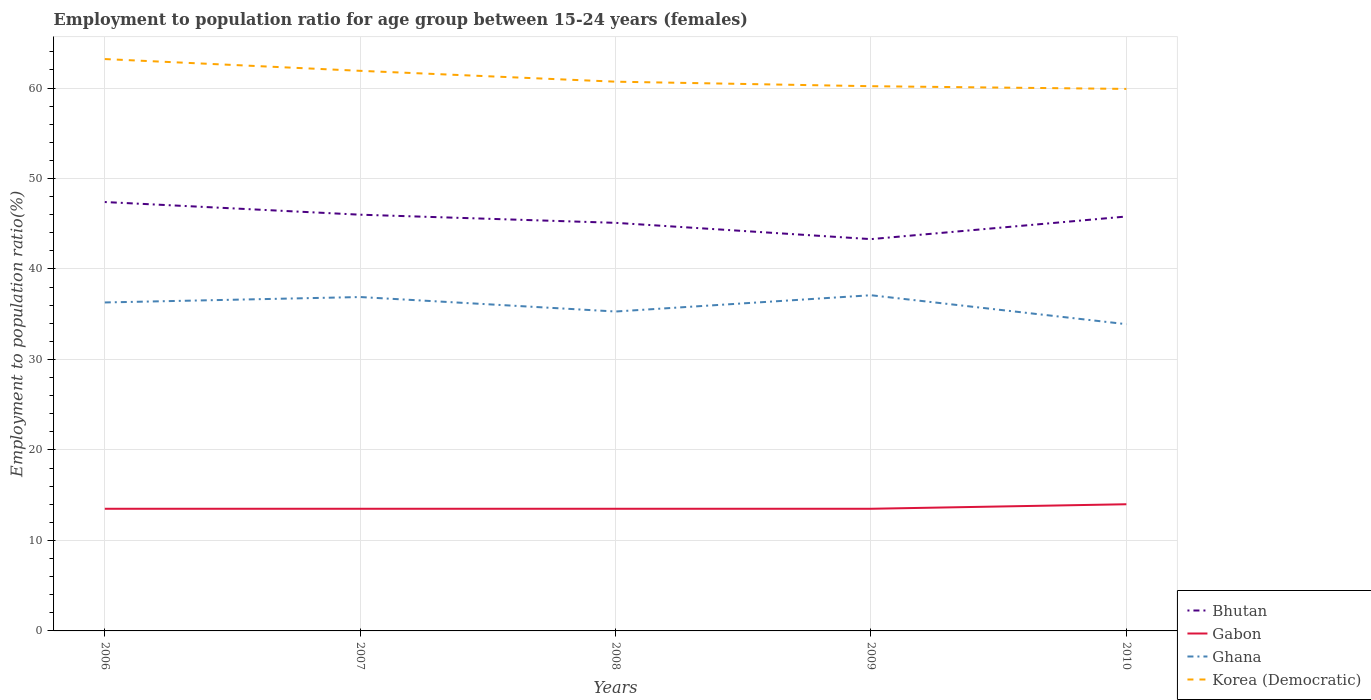How many different coloured lines are there?
Offer a very short reply. 4. Across all years, what is the maximum employment to population ratio in Korea (Democratic)?
Give a very brief answer. 59.9. What is the total employment to population ratio in Bhutan in the graph?
Offer a terse response. 0.9. What is the difference between the highest and the second highest employment to population ratio in Bhutan?
Provide a short and direct response. 4.1. How many years are there in the graph?
Give a very brief answer. 5. Are the values on the major ticks of Y-axis written in scientific E-notation?
Ensure brevity in your answer.  No. Does the graph contain any zero values?
Offer a very short reply. No. Does the graph contain grids?
Keep it short and to the point. Yes. How many legend labels are there?
Make the answer very short. 4. What is the title of the graph?
Your answer should be very brief. Employment to population ratio for age group between 15-24 years (females). Does "Least developed countries" appear as one of the legend labels in the graph?
Your response must be concise. No. What is the label or title of the X-axis?
Make the answer very short. Years. What is the Employment to population ratio(%) of Bhutan in 2006?
Offer a very short reply. 47.4. What is the Employment to population ratio(%) of Ghana in 2006?
Your answer should be compact. 36.3. What is the Employment to population ratio(%) of Korea (Democratic) in 2006?
Provide a short and direct response. 63.2. What is the Employment to population ratio(%) in Bhutan in 2007?
Make the answer very short. 46. What is the Employment to population ratio(%) in Ghana in 2007?
Your answer should be compact. 36.9. What is the Employment to population ratio(%) of Korea (Democratic) in 2007?
Provide a short and direct response. 61.9. What is the Employment to population ratio(%) of Bhutan in 2008?
Offer a terse response. 45.1. What is the Employment to population ratio(%) of Gabon in 2008?
Offer a terse response. 13.5. What is the Employment to population ratio(%) of Ghana in 2008?
Provide a short and direct response. 35.3. What is the Employment to population ratio(%) in Korea (Democratic) in 2008?
Your answer should be compact. 60.7. What is the Employment to population ratio(%) in Bhutan in 2009?
Make the answer very short. 43.3. What is the Employment to population ratio(%) of Ghana in 2009?
Your answer should be compact. 37.1. What is the Employment to population ratio(%) in Korea (Democratic) in 2009?
Keep it short and to the point. 60.2. What is the Employment to population ratio(%) of Bhutan in 2010?
Give a very brief answer. 45.8. What is the Employment to population ratio(%) in Ghana in 2010?
Offer a very short reply. 33.9. What is the Employment to population ratio(%) in Korea (Democratic) in 2010?
Make the answer very short. 59.9. Across all years, what is the maximum Employment to population ratio(%) of Bhutan?
Make the answer very short. 47.4. Across all years, what is the maximum Employment to population ratio(%) in Ghana?
Ensure brevity in your answer.  37.1. Across all years, what is the maximum Employment to population ratio(%) in Korea (Democratic)?
Provide a succinct answer. 63.2. Across all years, what is the minimum Employment to population ratio(%) of Bhutan?
Offer a terse response. 43.3. Across all years, what is the minimum Employment to population ratio(%) in Ghana?
Ensure brevity in your answer.  33.9. Across all years, what is the minimum Employment to population ratio(%) of Korea (Democratic)?
Offer a very short reply. 59.9. What is the total Employment to population ratio(%) of Bhutan in the graph?
Your response must be concise. 227.6. What is the total Employment to population ratio(%) of Ghana in the graph?
Offer a terse response. 179.5. What is the total Employment to population ratio(%) in Korea (Democratic) in the graph?
Offer a very short reply. 305.9. What is the difference between the Employment to population ratio(%) in Gabon in 2006 and that in 2007?
Keep it short and to the point. 0. What is the difference between the Employment to population ratio(%) of Gabon in 2006 and that in 2008?
Provide a succinct answer. 0. What is the difference between the Employment to population ratio(%) in Korea (Democratic) in 2006 and that in 2008?
Your answer should be compact. 2.5. What is the difference between the Employment to population ratio(%) of Bhutan in 2006 and that in 2009?
Make the answer very short. 4.1. What is the difference between the Employment to population ratio(%) of Bhutan in 2007 and that in 2008?
Give a very brief answer. 0.9. What is the difference between the Employment to population ratio(%) in Ghana in 2007 and that in 2008?
Your answer should be compact. 1.6. What is the difference between the Employment to population ratio(%) in Gabon in 2007 and that in 2009?
Make the answer very short. 0. What is the difference between the Employment to population ratio(%) in Ghana in 2007 and that in 2009?
Your answer should be very brief. -0.2. What is the difference between the Employment to population ratio(%) of Ghana in 2007 and that in 2010?
Provide a short and direct response. 3. What is the difference between the Employment to population ratio(%) in Bhutan in 2008 and that in 2009?
Your response must be concise. 1.8. What is the difference between the Employment to population ratio(%) in Korea (Democratic) in 2008 and that in 2009?
Offer a terse response. 0.5. What is the difference between the Employment to population ratio(%) in Gabon in 2009 and that in 2010?
Keep it short and to the point. -0.5. What is the difference between the Employment to population ratio(%) of Ghana in 2009 and that in 2010?
Your response must be concise. 3.2. What is the difference between the Employment to population ratio(%) of Korea (Democratic) in 2009 and that in 2010?
Provide a short and direct response. 0.3. What is the difference between the Employment to population ratio(%) in Bhutan in 2006 and the Employment to population ratio(%) in Gabon in 2007?
Make the answer very short. 33.9. What is the difference between the Employment to population ratio(%) of Gabon in 2006 and the Employment to population ratio(%) of Ghana in 2007?
Make the answer very short. -23.4. What is the difference between the Employment to population ratio(%) of Gabon in 2006 and the Employment to population ratio(%) of Korea (Democratic) in 2007?
Your answer should be compact. -48.4. What is the difference between the Employment to population ratio(%) of Ghana in 2006 and the Employment to population ratio(%) of Korea (Democratic) in 2007?
Make the answer very short. -25.6. What is the difference between the Employment to population ratio(%) in Bhutan in 2006 and the Employment to population ratio(%) in Gabon in 2008?
Keep it short and to the point. 33.9. What is the difference between the Employment to population ratio(%) of Bhutan in 2006 and the Employment to population ratio(%) of Korea (Democratic) in 2008?
Your answer should be compact. -13.3. What is the difference between the Employment to population ratio(%) of Gabon in 2006 and the Employment to population ratio(%) of Ghana in 2008?
Offer a terse response. -21.8. What is the difference between the Employment to population ratio(%) of Gabon in 2006 and the Employment to population ratio(%) of Korea (Democratic) in 2008?
Keep it short and to the point. -47.2. What is the difference between the Employment to population ratio(%) in Ghana in 2006 and the Employment to population ratio(%) in Korea (Democratic) in 2008?
Give a very brief answer. -24.4. What is the difference between the Employment to population ratio(%) in Bhutan in 2006 and the Employment to population ratio(%) in Gabon in 2009?
Your response must be concise. 33.9. What is the difference between the Employment to population ratio(%) in Bhutan in 2006 and the Employment to population ratio(%) in Ghana in 2009?
Offer a very short reply. 10.3. What is the difference between the Employment to population ratio(%) of Bhutan in 2006 and the Employment to population ratio(%) of Korea (Democratic) in 2009?
Your answer should be very brief. -12.8. What is the difference between the Employment to population ratio(%) in Gabon in 2006 and the Employment to population ratio(%) in Ghana in 2009?
Make the answer very short. -23.6. What is the difference between the Employment to population ratio(%) in Gabon in 2006 and the Employment to population ratio(%) in Korea (Democratic) in 2009?
Provide a succinct answer. -46.7. What is the difference between the Employment to population ratio(%) in Ghana in 2006 and the Employment to population ratio(%) in Korea (Democratic) in 2009?
Provide a short and direct response. -23.9. What is the difference between the Employment to population ratio(%) of Bhutan in 2006 and the Employment to population ratio(%) of Gabon in 2010?
Give a very brief answer. 33.4. What is the difference between the Employment to population ratio(%) in Bhutan in 2006 and the Employment to population ratio(%) in Ghana in 2010?
Keep it short and to the point. 13.5. What is the difference between the Employment to population ratio(%) in Gabon in 2006 and the Employment to population ratio(%) in Ghana in 2010?
Offer a terse response. -20.4. What is the difference between the Employment to population ratio(%) in Gabon in 2006 and the Employment to population ratio(%) in Korea (Democratic) in 2010?
Your response must be concise. -46.4. What is the difference between the Employment to population ratio(%) of Ghana in 2006 and the Employment to population ratio(%) of Korea (Democratic) in 2010?
Offer a very short reply. -23.6. What is the difference between the Employment to population ratio(%) of Bhutan in 2007 and the Employment to population ratio(%) of Gabon in 2008?
Make the answer very short. 32.5. What is the difference between the Employment to population ratio(%) in Bhutan in 2007 and the Employment to population ratio(%) in Korea (Democratic) in 2008?
Offer a very short reply. -14.7. What is the difference between the Employment to population ratio(%) of Gabon in 2007 and the Employment to population ratio(%) of Ghana in 2008?
Make the answer very short. -21.8. What is the difference between the Employment to population ratio(%) in Gabon in 2007 and the Employment to population ratio(%) in Korea (Democratic) in 2008?
Ensure brevity in your answer.  -47.2. What is the difference between the Employment to population ratio(%) in Ghana in 2007 and the Employment to population ratio(%) in Korea (Democratic) in 2008?
Your response must be concise. -23.8. What is the difference between the Employment to population ratio(%) of Bhutan in 2007 and the Employment to population ratio(%) of Gabon in 2009?
Offer a very short reply. 32.5. What is the difference between the Employment to population ratio(%) in Bhutan in 2007 and the Employment to population ratio(%) in Ghana in 2009?
Make the answer very short. 8.9. What is the difference between the Employment to population ratio(%) in Gabon in 2007 and the Employment to population ratio(%) in Ghana in 2009?
Your answer should be very brief. -23.6. What is the difference between the Employment to population ratio(%) in Gabon in 2007 and the Employment to population ratio(%) in Korea (Democratic) in 2009?
Offer a very short reply. -46.7. What is the difference between the Employment to population ratio(%) in Ghana in 2007 and the Employment to population ratio(%) in Korea (Democratic) in 2009?
Provide a short and direct response. -23.3. What is the difference between the Employment to population ratio(%) of Bhutan in 2007 and the Employment to population ratio(%) of Gabon in 2010?
Make the answer very short. 32. What is the difference between the Employment to population ratio(%) of Bhutan in 2007 and the Employment to population ratio(%) of Ghana in 2010?
Give a very brief answer. 12.1. What is the difference between the Employment to population ratio(%) in Gabon in 2007 and the Employment to population ratio(%) in Ghana in 2010?
Your answer should be very brief. -20.4. What is the difference between the Employment to population ratio(%) of Gabon in 2007 and the Employment to population ratio(%) of Korea (Democratic) in 2010?
Provide a short and direct response. -46.4. What is the difference between the Employment to population ratio(%) in Bhutan in 2008 and the Employment to population ratio(%) in Gabon in 2009?
Your answer should be compact. 31.6. What is the difference between the Employment to population ratio(%) in Bhutan in 2008 and the Employment to population ratio(%) in Ghana in 2009?
Your response must be concise. 8. What is the difference between the Employment to population ratio(%) in Bhutan in 2008 and the Employment to population ratio(%) in Korea (Democratic) in 2009?
Ensure brevity in your answer.  -15.1. What is the difference between the Employment to population ratio(%) of Gabon in 2008 and the Employment to population ratio(%) of Ghana in 2009?
Your response must be concise. -23.6. What is the difference between the Employment to population ratio(%) in Gabon in 2008 and the Employment to population ratio(%) in Korea (Democratic) in 2009?
Your response must be concise. -46.7. What is the difference between the Employment to population ratio(%) in Ghana in 2008 and the Employment to population ratio(%) in Korea (Democratic) in 2009?
Provide a short and direct response. -24.9. What is the difference between the Employment to population ratio(%) of Bhutan in 2008 and the Employment to population ratio(%) of Gabon in 2010?
Offer a very short reply. 31.1. What is the difference between the Employment to population ratio(%) of Bhutan in 2008 and the Employment to population ratio(%) of Korea (Democratic) in 2010?
Your answer should be very brief. -14.8. What is the difference between the Employment to population ratio(%) of Gabon in 2008 and the Employment to population ratio(%) of Ghana in 2010?
Your answer should be very brief. -20.4. What is the difference between the Employment to population ratio(%) in Gabon in 2008 and the Employment to population ratio(%) in Korea (Democratic) in 2010?
Offer a terse response. -46.4. What is the difference between the Employment to population ratio(%) in Ghana in 2008 and the Employment to population ratio(%) in Korea (Democratic) in 2010?
Provide a short and direct response. -24.6. What is the difference between the Employment to population ratio(%) of Bhutan in 2009 and the Employment to population ratio(%) of Gabon in 2010?
Make the answer very short. 29.3. What is the difference between the Employment to population ratio(%) in Bhutan in 2009 and the Employment to population ratio(%) in Korea (Democratic) in 2010?
Keep it short and to the point. -16.6. What is the difference between the Employment to population ratio(%) in Gabon in 2009 and the Employment to population ratio(%) in Ghana in 2010?
Provide a short and direct response. -20.4. What is the difference between the Employment to population ratio(%) of Gabon in 2009 and the Employment to population ratio(%) of Korea (Democratic) in 2010?
Provide a succinct answer. -46.4. What is the difference between the Employment to population ratio(%) in Ghana in 2009 and the Employment to population ratio(%) in Korea (Democratic) in 2010?
Offer a very short reply. -22.8. What is the average Employment to population ratio(%) in Bhutan per year?
Your answer should be compact. 45.52. What is the average Employment to population ratio(%) in Gabon per year?
Make the answer very short. 13.6. What is the average Employment to population ratio(%) in Ghana per year?
Give a very brief answer. 35.9. What is the average Employment to population ratio(%) in Korea (Democratic) per year?
Provide a succinct answer. 61.18. In the year 2006, what is the difference between the Employment to population ratio(%) of Bhutan and Employment to population ratio(%) of Gabon?
Make the answer very short. 33.9. In the year 2006, what is the difference between the Employment to population ratio(%) in Bhutan and Employment to population ratio(%) in Ghana?
Your answer should be compact. 11.1. In the year 2006, what is the difference between the Employment to population ratio(%) of Bhutan and Employment to population ratio(%) of Korea (Democratic)?
Offer a terse response. -15.8. In the year 2006, what is the difference between the Employment to population ratio(%) of Gabon and Employment to population ratio(%) of Ghana?
Make the answer very short. -22.8. In the year 2006, what is the difference between the Employment to population ratio(%) in Gabon and Employment to population ratio(%) in Korea (Democratic)?
Offer a terse response. -49.7. In the year 2006, what is the difference between the Employment to population ratio(%) in Ghana and Employment to population ratio(%) in Korea (Democratic)?
Provide a short and direct response. -26.9. In the year 2007, what is the difference between the Employment to population ratio(%) in Bhutan and Employment to population ratio(%) in Gabon?
Offer a very short reply. 32.5. In the year 2007, what is the difference between the Employment to population ratio(%) of Bhutan and Employment to population ratio(%) of Korea (Democratic)?
Your answer should be compact. -15.9. In the year 2007, what is the difference between the Employment to population ratio(%) of Gabon and Employment to population ratio(%) of Ghana?
Your response must be concise. -23.4. In the year 2007, what is the difference between the Employment to population ratio(%) of Gabon and Employment to population ratio(%) of Korea (Democratic)?
Offer a very short reply. -48.4. In the year 2007, what is the difference between the Employment to population ratio(%) in Ghana and Employment to population ratio(%) in Korea (Democratic)?
Your answer should be compact. -25. In the year 2008, what is the difference between the Employment to population ratio(%) in Bhutan and Employment to population ratio(%) in Gabon?
Provide a succinct answer. 31.6. In the year 2008, what is the difference between the Employment to population ratio(%) in Bhutan and Employment to population ratio(%) in Ghana?
Provide a short and direct response. 9.8. In the year 2008, what is the difference between the Employment to population ratio(%) of Bhutan and Employment to population ratio(%) of Korea (Democratic)?
Your response must be concise. -15.6. In the year 2008, what is the difference between the Employment to population ratio(%) of Gabon and Employment to population ratio(%) of Ghana?
Your response must be concise. -21.8. In the year 2008, what is the difference between the Employment to population ratio(%) of Gabon and Employment to population ratio(%) of Korea (Democratic)?
Make the answer very short. -47.2. In the year 2008, what is the difference between the Employment to population ratio(%) in Ghana and Employment to population ratio(%) in Korea (Democratic)?
Your answer should be compact. -25.4. In the year 2009, what is the difference between the Employment to population ratio(%) of Bhutan and Employment to population ratio(%) of Gabon?
Provide a succinct answer. 29.8. In the year 2009, what is the difference between the Employment to population ratio(%) in Bhutan and Employment to population ratio(%) in Ghana?
Your answer should be very brief. 6.2. In the year 2009, what is the difference between the Employment to population ratio(%) in Bhutan and Employment to population ratio(%) in Korea (Democratic)?
Your response must be concise. -16.9. In the year 2009, what is the difference between the Employment to population ratio(%) in Gabon and Employment to population ratio(%) in Ghana?
Offer a very short reply. -23.6. In the year 2009, what is the difference between the Employment to population ratio(%) of Gabon and Employment to population ratio(%) of Korea (Democratic)?
Make the answer very short. -46.7. In the year 2009, what is the difference between the Employment to population ratio(%) of Ghana and Employment to population ratio(%) of Korea (Democratic)?
Give a very brief answer. -23.1. In the year 2010, what is the difference between the Employment to population ratio(%) in Bhutan and Employment to population ratio(%) in Gabon?
Ensure brevity in your answer.  31.8. In the year 2010, what is the difference between the Employment to population ratio(%) in Bhutan and Employment to population ratio(%) in Korea (Democratic)?
Give a very brief answer. -14.1. In the year 2010, what is the difference between the Employment to population ratio(%) of Gabon and Employment to population ratio(%) of Ghana?
Provide a succinct answer. -19.9. In the year 2010, what is the difference between the Employment to population ratio(%) of Gabon and Employment to population ratio(%) of Korea (Democratic)?
Keep it short and to the point. -45.9. In the year 2010, what is the difference between the Employment to population ratio(%) in Ghana and Employment to population ratio(%) in Korea (Democratic)?
Your response must be concise. -26. What is the ratio of the Employment to population ratio(%) in Bhutan in 2006 to that in 2007?
Offer a very short reply. 1.03. What is the ratio of the Employment to population ratio(%) in Ghana in 2006 to that in 2007?
Ensure brevity in your answer.  0.98. What is the ratio of the Employment to population ratio(%) in Korea (Democratic) in 2006 to that in 2007?
Keep it short and to the point. 1.02. What is the ratio of the Employment to population ratio(%) of Bhutan in 2006 to that in 2008?
Make the answer very short. 1.05. What is the ratio of the Employment to population ratio(%) in Gabon in 2006 to that in 2008?
Your answer should be very brief. 1. What is the ratio of the Employment to population ratio(%) in Ghana in 2006 to that in 2008?
Ensure brevity in your answer.  1.03. What is the ratio of the Employment to population ratio(%) in Korea (Democratic) in 2006 to that in 2008?
Ensure brevity in your answer.  1.04. What is the ratio of the Employment to population ratio(%) in Bhutan in 2006 to that in 2009?
Provide a short and direct response. 1.09. What is the ratio of the Employment to population ratio(%) in Gabon in 2006 to that in 2009?
Provide a succinct answer. 1. What is the ratio of the Employment to population ratio(%) of Ghana in 2006 to that in 2009?
Offer a very short reply. 0.98. What is the ratio of the Employment to population ratio(%) in Korea (Democratic) in 2006 to that in 2009?
Ensure brevity in your answer.  1.05. What is the ratio of the Employment to population ratio(%) of Bhutan in 2006 to that in 2010?
Your response must be concise. 1.03. What is the ratio of the Employment to population ratio(%) of Ghana in 2006 to that in 2010?
Your answer should be very brief. 1.07. What is the ratio of the Employment to population ratio(%) in Korea (Democratic) in 2006 to that in 2010?
Your answer should be very brief. 1.06. What is the ratio of the Employment to population ratio(%) in Ghana in 2007 to that in 2008?
Provide a succinct answer. 1.05. What is the ratio of the Employment to population ratio(%) of Korea (Democratic) in 2007 to that in 2008?
Give a very brief answer. 1.02. What is the ratio of the Employment to population ratio(%) in Bhutan in 2007 to that in 2009?
Make the answer very short. 1.06. What is the ratio of the Employment to population ratio(%) of Gabon in 2007 to that in 2009?
Provide a succinct answer. 1. What is the ratio of the Employment to population ratio(%) of Korea (Democratic) in 2007 to that in 2009?
Make the answer very short. 1.03. What is the ratio of the Employment to population ratio(%) in Gabon in 2007 to that in 2010?
Make the answer very short. 0.96. What is the ratio of the Employment to population ratio(%) in Ghana in 2007 to that in 2010?
Provide a short and direct response. 1.09. What is the ratio of the Employment to population ratio(%) of Korea (Democratic) in 2007 to that in 2010?
Offer a terse response. 1.03. What is the ratio of the Employment to population ratio(%) in Bhutan in 2008 to that in 2009?
Offer a very short reply. 1.04. What is the ratio of the Employment to population ratio(%) in Ghana in 2008 to that in 2009?
Keep it short and to the point. 0.95. What is the ratio of the Employment to population ratio(%) of Korea (Democratic) in 2008 to that in 2009?
Provide a short and direct response. 1.01. What is the ratio of the Employment to population ratio(%) in Bhutan in 2008 to that in 2010?
Provide a short and direct response. 0.98. What is the ratio of the Employment to population ratio(%) of Gabon in 2008 to that in 2010?
Offer a terse response. 0.96. What is the ratio of the Employment to population ratio(%) in Ghana in 2008 to that in 2010?
Give a very brief answer. 1.04. What is the ratio of the Employment to population ratio(%) of Korea (Democratic) in 2008 to that in 2010?
Make the answer very short. 1.01. What is the ratio of the Employment to population ratio(%) of Bhutan in 2009 to that in 2010?
Your answer should be compact. 0.95. What is the ratio of the Employment to population ratio(%) in Ghana in 2009 to that in 2010?
Your response must be concise. 1.09. What is the ratio of the Employment to population ratio(%) in Korea (Democratic) in 2009 to that in 2010?
Offer a very short reply. 1. What is the difference between the highest and the second highest Employment to population ratio(%) of Bhutan?
Offer a terse response. 1.4. What is the difference between the highest and the second highest Employment to population ratio(%) of Gabon?
Your answer should be very brief. 0.5. What is the difference between the highest and the second highest Employment to population ratio(%) of Ghana?
Ensure brevity in your answer.  0.2. What is the difference between the highest and the lowest Employment to population ratio(%) in Korea (Democratic)?
Your answer should be compact. 3.3. 